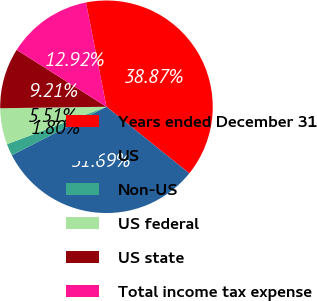<chart> <loc_0><loc_0><loc_500><loc_500><pie_chart><fcel>Years ended December 31<fcel>US<fcel>Non-US<fcel>US federal<fcel>US state<fcel>Total income tax expense<nl><fcel>38.87%<fcel>31.69%<fcel>1.8%<fcel>5.51%<fcel>9.21%<fcel>12.92%<nl></chart> 